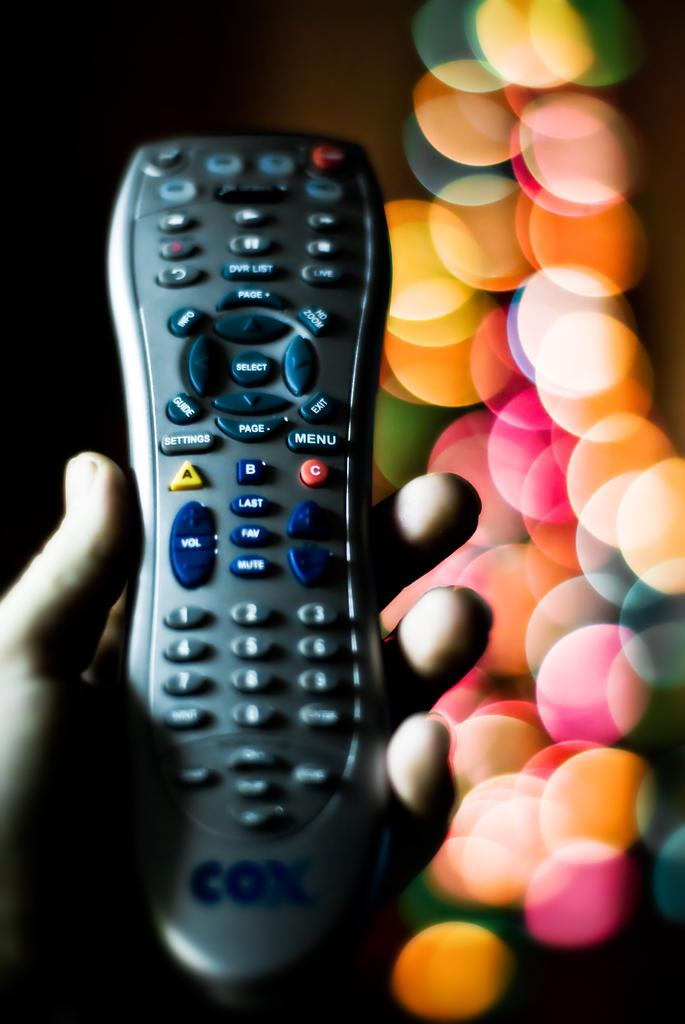What is the person in the image holding? The person is holding a remote in the image. What colors are the buttons on the remote? The remote has red, yellow, black, ash, and blue buttons. What can be seen in the background of the image? There are different color bubbles visible in the background of the image. Where is the zoo located in the image? There is no zoo present in the image. What type of clam is visible in the image? There are no clams present in the image. 